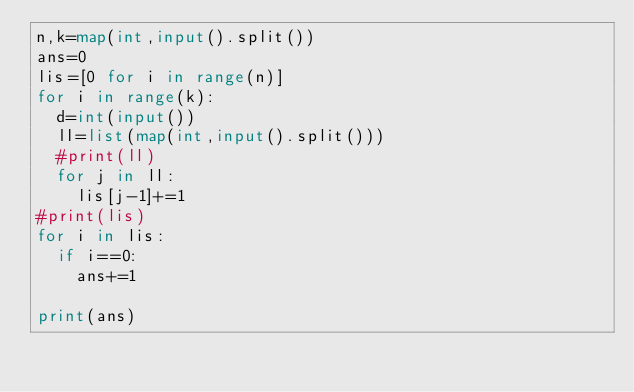Convert code to text. <code><loc_0><loc_0><loc_500><loc_500><_Python_>n,k=map(int,input().split())
ans=0
lis=[0 for i in range(n)]
for i in range(k):
  d=int(input())
  ll=list(map(int,input().split()))
  #print(ll)
  for j in ll:
    lis[j-1]+=1
#print(lis)
for i in lis:
  if i==0:
    ans+=1
    
print(ans)</code> 